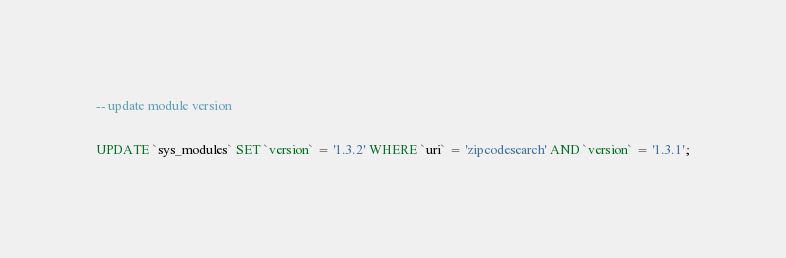Convert code to text. <code><loc_0><loc_0><loc_500><loc_500><_SQL_>

-- update module version

UPDATE `sys_modules` SET `version` = '1.3.2' WHERE `uri` = 'zipcodesearch' AND `version` = '1.3.1';

</code> 